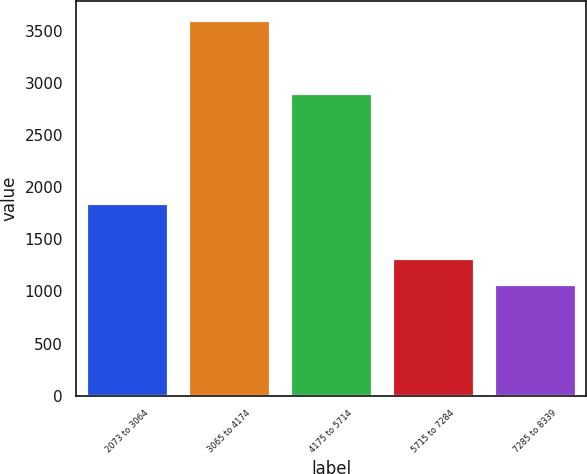Convert chart. <chart><loc_0><loc_0><loc_500><loc_500><bar_chart><fcel>2073 to 3064<fcel>3065 to 4174<fcel>4175 to 5714<fcel>5715 to 7284<fcel>7285 to 8339<nl><fcel>1854<fcel>3612<fcel>2908<fcel>1326<fcel>1072<nl></chart> 